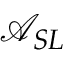<formula> <loc_0><loc_0><loc_500><loc_500>\mathcal { A } _ { S L }</formula> 